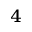Convert formula to latex. <formula><loc_0><loc_0><loc_500><loc_500>_ { 4 }</formula> 